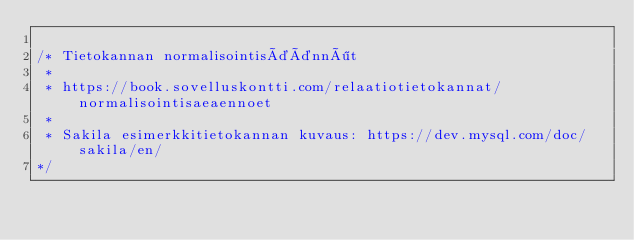<code> <loc_0><loc_0><loc_500><loc_500><_SQL_>
/* Tietokannan normalisointisäännöt
 * 
 * https://book.sovelluskontti.com/relaatiotietokannat/normalisointisaeaennoet
 * 
 * Sakila esimerkkitietokannan kuvaus: https://dev.mysql.com/doc/sakila/en/
*/ 










</code> 